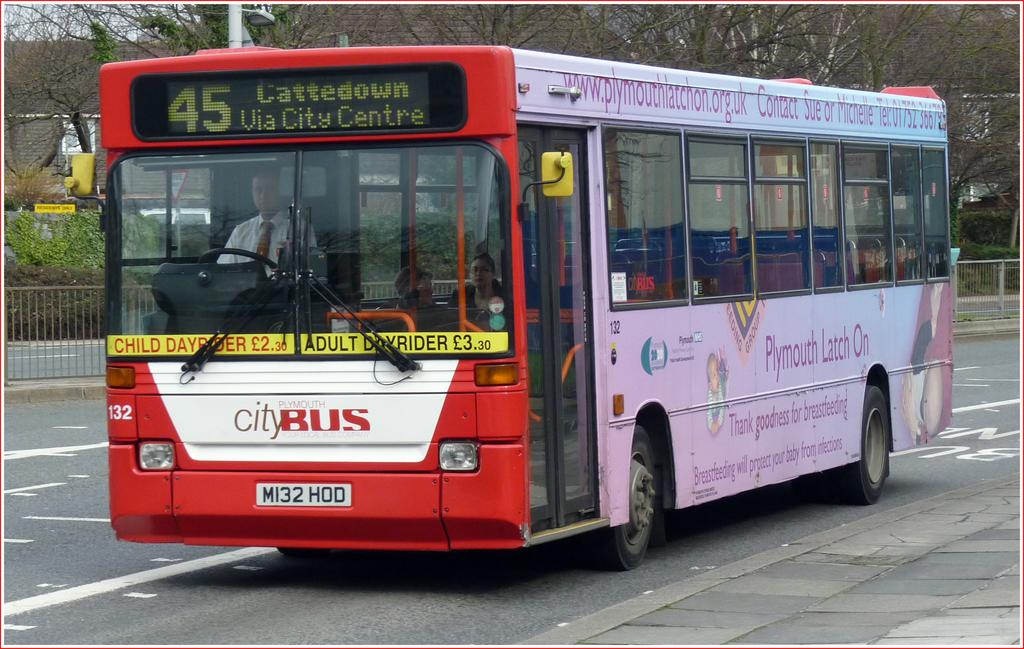<image>
Present a compact description of the photo's key features. The city bus is headed towards Cattedown via City Centre. 